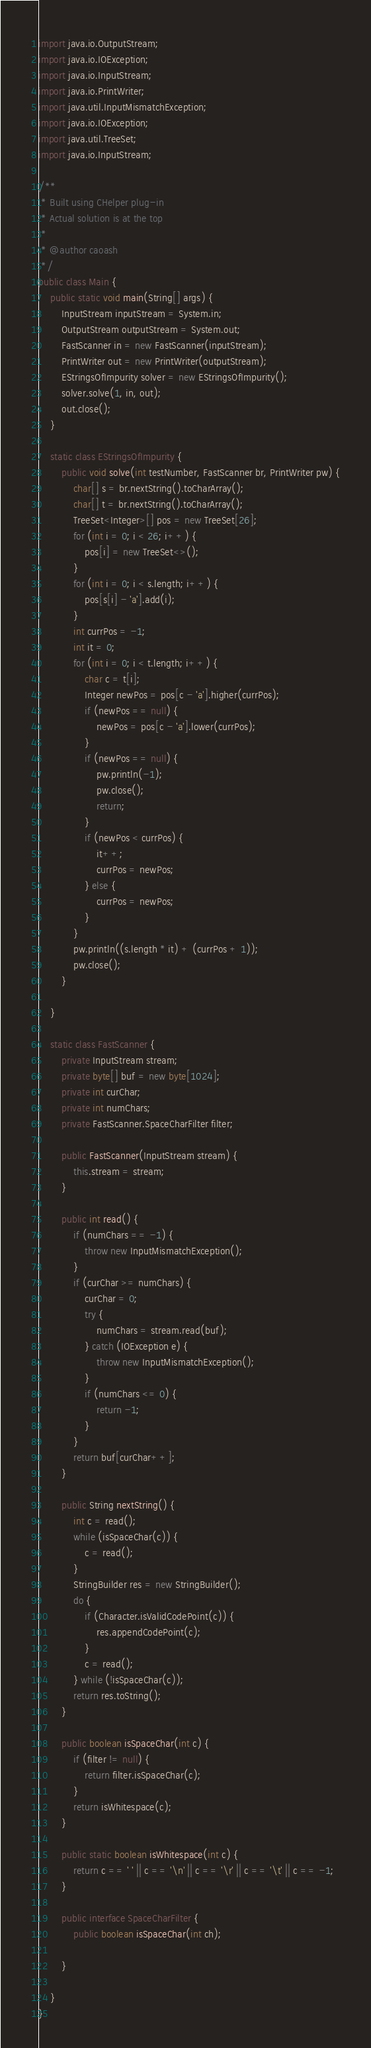<code> <loc_0><loc_0><loc_500><loc_500><_Java_>import java.io.OutputStream;
import java.io.IOException;
import java.io.InputStream;
import java.io.PrintWriter;
import java.util.InputMismatchException;
import java.io.IOException;
import java.util.TreeSet;
import java.io.InputStream;

/**
 * Built using CHelper plug-in
 * Actual solution is at the top
 *
 * @author caoash
 */
public class Main {
    public static void main(String[] args) {
        InputStream inputStream = System.in;
        OutputStream outputStream = System.out;
        FastScanner in = new FastScanner(inputStream);
        PrintWriter out = new PrintWriter(outputStream);
        EStringsOfImpurity solver = new EStringsOfImpurity();
        solver.solve(1, in, out);
        out.close();
    }

    static class EStringsOfImpurity {
        public void solve(int testNumber, FastScanner br, PrintWriter pw) {
            char[] s = br.nextString().toCharArray();
            char[] t = br.nextString().toCharArray();
            TreeSet<Integer>[] pos = new TreeSet[26];
            for (int i = 0; i < 26; i++) {
                pos[i] = new TreeSet<>();
            }
            for (int i = 0; i < s.length; i++) {
                pos[s[i] - 'a'].add(i);
            }
            int currPos = -1;
            int it = 0;
            for (int i = 0; i < t.length; i++) {
                char c = t[i];
                Integer newPos = pos[c - 'a'].higher(currPos);
                if (newPos == null) {
                    newPos = pos[c - 'a'].lower(currPos);
                }
                if (newPos == null) {
                    pw.println(-1);
                    pw.close();
                    return;
                }
                if (newPos < currPos) {
                    it++;
                    currPos = newPos;
                } else {
                    currPos = newPos;
                }
            }
            pw.println((s.length * it) + (currPos + 1));
            pw.close();
        }

    }

    static class FastScanner {
        private InputStream stream;
        private byte[] buf = new byte[1024];
        private int curChar;
        private int numChars;
        private FastScanner.SpaceCharFilter filter;

        public FastScanner(InputStream stream) {
            this.stream = stream;
        }

        public int read() {
            if (numChars == -1) {
                throw new InputMismatchException();
            }
            if (curChar >= numChars) {
                curChar = 0;
                try {
                    numChars = stream.read(buf);
                } catch (IOException e) {
                    throw new InputMismatchException();
                }
                if (numChars <= 0) {
                    return -1;
                }
            }
            return buf[curChar++];
        }

        public String nextString() {
            int c = read();
            while (isSpaceChar(c)) {
                c = read();
            }
            StringBuilder res = new StringBuilder();
            do {
                if (Character.isValidCodePoint(c)) {
                    res.appendCodePoint(c);
                }
                c = read();
            } while (!isSpaceChar(c));
            return res.toString();
        }

        public boolean isSpaceChar(int c) {
            if (filter != null) {
                return filter.isSpaceChar(c);
            }
            return isWhitespace(c);
        }

        public static boolean isWhitespace(int c) {
            return c == ' ' || c == '\n' || c == '\r' || c == '\t' || c == -1;
        }

        public interface SpaceCharFilter {
            public boolean isSpaceChar(int ch);

        }

    }
}

</code> 